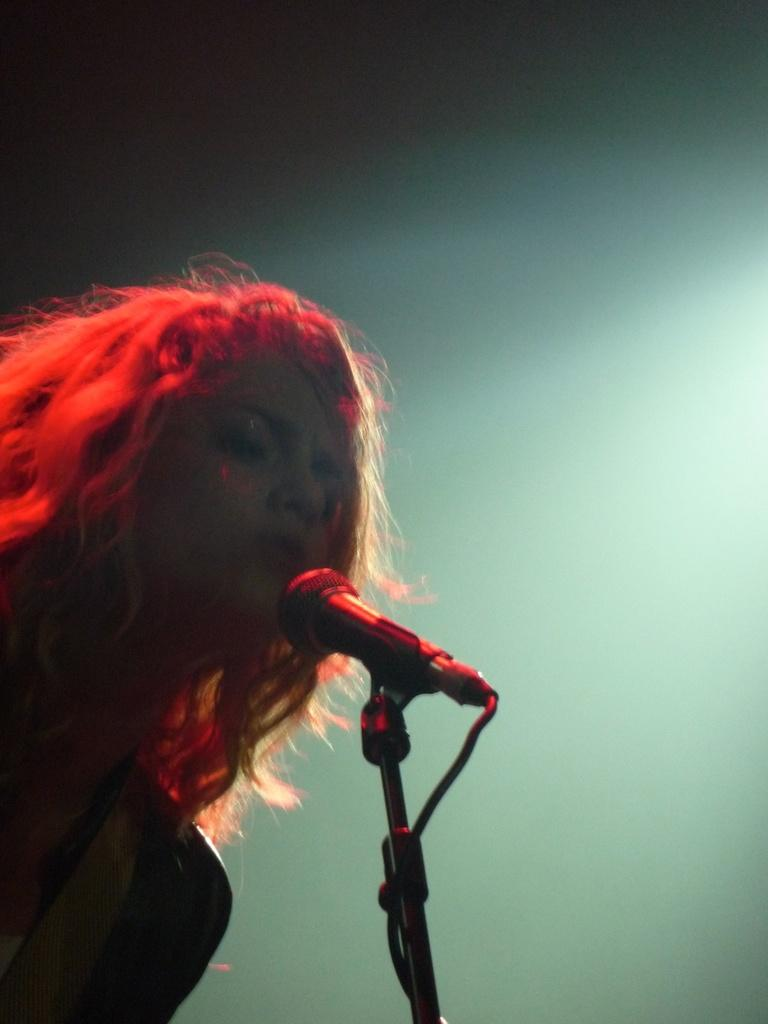Who is the main subject in the image? There is a woman in the image. What is the woman doing in the image? The woman is singing. What object is the woman holding in the image? The woman is holding a mic. Where is the rifle located in the image? There is no rifle present in the image. What type of meeting is the woman attending in the image? There is no meeting depicted in the image; the woman is singing while holding a mic. 